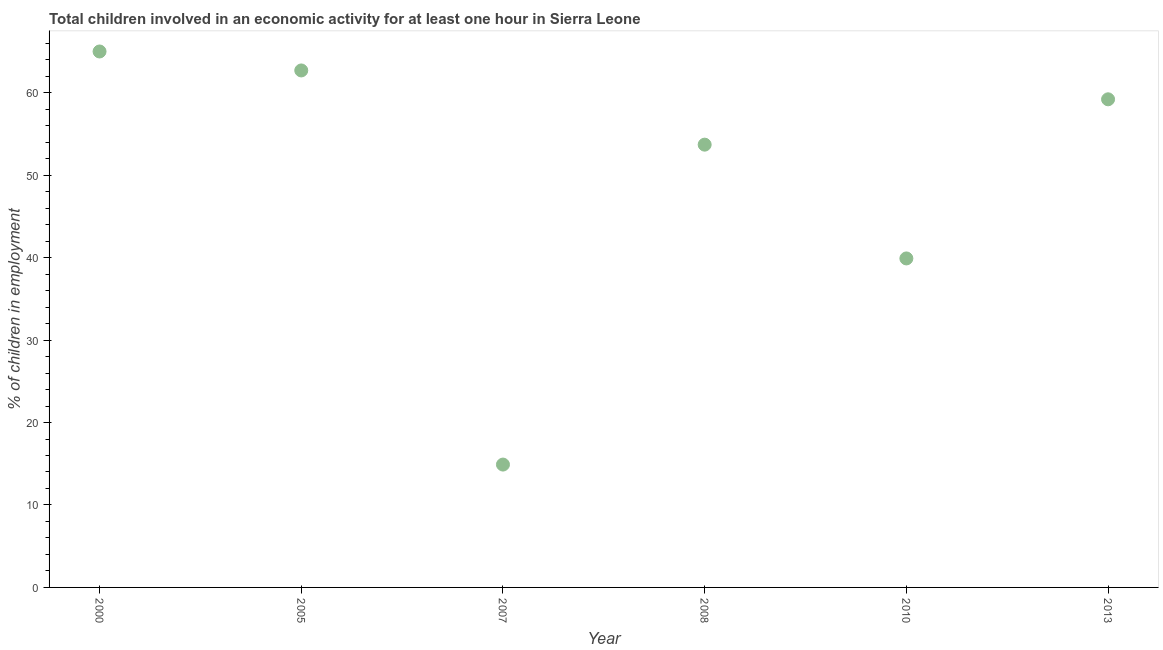What is the percentage of children in employment in 2005?
Give a very brief answer. 62.7. What is the sum of the percentage of children in employment?
Your answer should be compact. 295.4. What is the difference between the percentage of children in employment in 2010 and 2013?
Give a very brief answer. -19.3. What is the average percentage of children in employment per year?
Offer a very short reply. 49.23. What is the median percentage of children in employment?
Provide a succinct answer. 56.45. In how many years, is the percentage of children in employment greater than 58 %?
Offer a very short reply. 3. Do a majority of the years between 2007 and 2005 (inclusive) have percentage of children in employment greater than 20 %?
Ensure brevity in your answer.  No. What is the ratio of the percentage of children in employment in 2008 to that in 2013?
Give a very brief answer. 0.91. Is the difference between the percentage of children in employment in 2008 and 2013 greater than the difference between any two years?
Your response must be concise. No. What is the difference between the highest and the second highest percentage of children in employment?
Offer a terse response. 2.3. What is the difference between the highest and the lowest percentage of children in employment?
Provide a succinct answer. 50.1. Does the percentage of children in employment monotonically increase over the years?
Your answer should be compact. No. What is the difference between two consecutive major ticks on the Y-axis?
Give a very brief answer. 10. What is the title of the graph?
Offer a terse response. Total children involved in an economic activity for at least one hour in Sierra Leone. What is the label or title of the Y-axis?
Give a very brief answer. % of children in employment. What is the % of children in employment in 2005?
Your answer should be very brief. 62.7. What is the % of children in employment in 2008?
Ensure brevity in your answer.  53.7. What is the % of children in employment in 2010?
Make the answer very short. 39.9. What is the % of children in employment in 2013?
Provide a succinct answer. 59.2. What is the difference between the % of children in employment in 2000 and 2007?
Provide a short and direct response. 50.1. What is the difference between the % of children in employment in 2000 and 2010?
Provide a short and direct response. 25.1. What is the difference between the % of children in employment in 2000 and 2013?
Your answer should be compact. 5.8. What is the difference between the % of children in employment in 2005 and 2007?
Give a very brief answer. 47.8. What is the difference between the % of children in employment in 2005 and 2008?
Give a very brief answer. 9. What is the difference between the % of children in employment in 2005 and 2010?
Provide a short and direct response. 22.8. What is the difference between the % of children in employment in 2007 and 2008?
Your answer should be very brief. -38.8. What is the difference between the % of children in employment in 2007 and 2013?
Offer a very short reply. -44.3. What is the difference between the % of children in employment in 2008 and 2010?
Your answer should be very brief. 13.8. What is the difference between the % of children in employment in 2008 and 2013?
Ensure brevity in your answer.  -5.5. What is the difference between the % of children in employment in 2010 and 2013?
Your answer should be compact. -19.3. What is the ratio of the % of children in employment in 2000 to that in 2005?
Give a very brief answer. 1.04. What is the ratio of the % of children in employment in 2000 to that in 2007?
Give a very brief answer. 4.36. What is the ratio of the % of children in employment in 2000 to that in 2008?
Give a very brief answer. 1.21. What is the ratio of the % of children in employment in 2000 to that in 2010?
Your answer should be very brief. 1.63. What is the ratio of the % of children in employment in 2000 to that in 2013?
Your answer should be very brief. 1.1. What is the ratio of the % of children in employment in 2005 to that in 2007?
Provide a short and direct response. 4.21. What is the ratio of the % of children in employment in 2005 to that in 2008?
Your answer should be compact. 1.17. What is the ratio of the % of children in employment in 2005 to that in 2010?
Provide a short and direct response. 1.57. What is the ratio of the % of children in employment in 2005 to that in 2013?
Ensure brevity in your answer.  1.06. What is the ratio of the % of children in employment in 2007 to that in 2008?
Keep it short and to the point. 0.28. What is the ratio of the % of children in employment in 2007 to that in 2010?
Your response must be concise. 0.37. What is the ratio of the % of children in employment in 2007 to that in 2013?
Your answer should be compact. 0.25. What is the ratio of the % of children in employment in 2008 to that in 2010?
Your answer should be very brief. 1.35. What is the ratio of the % of children in employment in 2008 to that in 2013?
Ensure brevity in your answer.  0.91. What is the ratio of the % of children in employment in 2010 to that in 2013?
Your answer should be very brief. 0.67. 